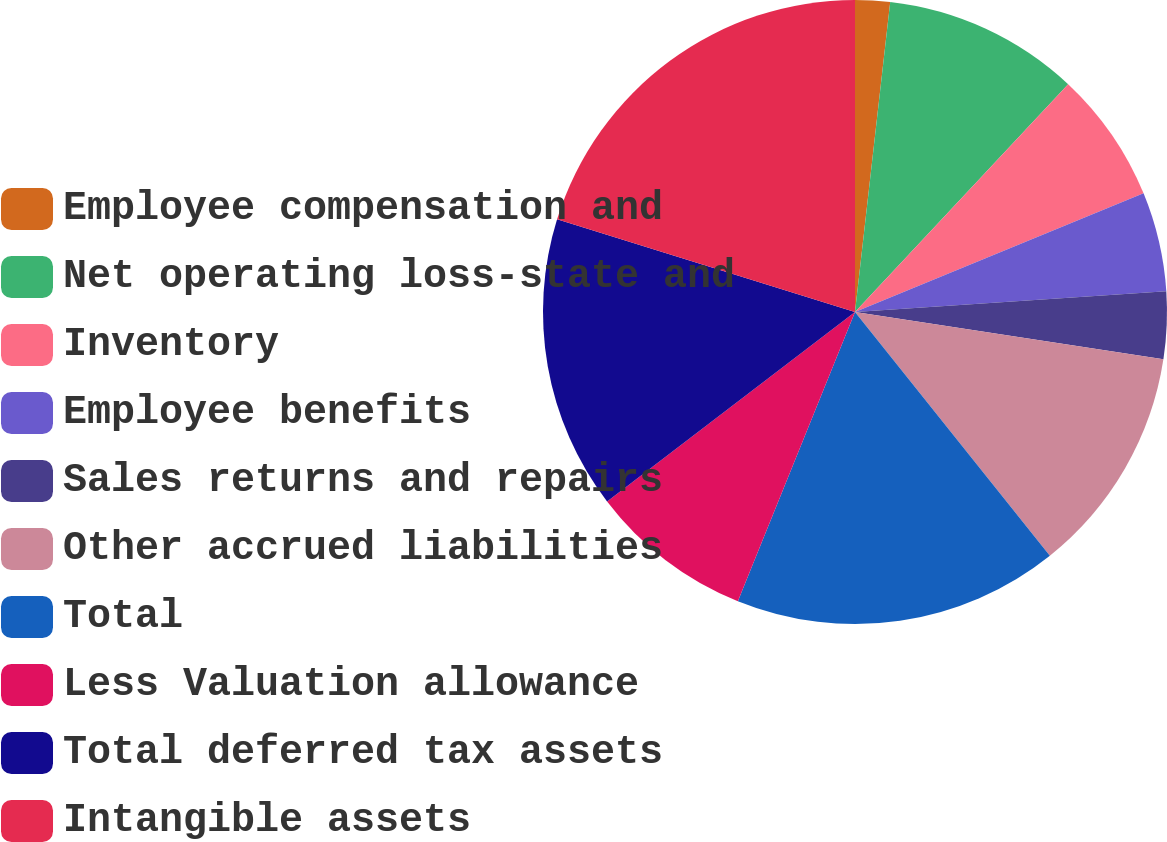Convert chart. <chart><loc_0><loc_0><loc_500><loc_500><pie_chart><fcel>Employee compensation and<fcel>Net operating loss-state and<fcel>Inventory<fcel>Employee benefits<fcel>Sales returns and repairs<fcel>Other accrued liabilities<fcel>Total<fcel>Less Valuation allowance<fcel>Total deferred tax assets<fcel>Intangible assets<nl><fcel>1.8%<fcel>10.17%<fcel>6.82%<fcel>5.15%<fcel>3.48%<fcel>11.84%<fcel>16.86%<fcel>8.49%<fcel>15.18%<fcel>20.2%<nl></chart> 